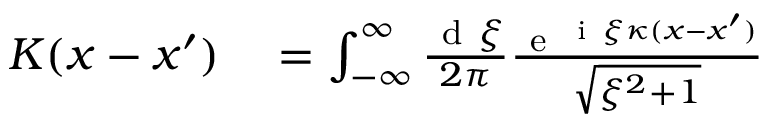<formula> <loc_0><loc_0><loc_500><loc_500>\begin{array} { r l } { K ( x - x ^ { \prime } ) } & = \int _ { - \infty } ^ { \infty } \frac { d \xi } { 2 \pi } \frac { e ^ { i \xi \kappa ( x - x ^ { \prime } ) } } { \sqrt { \xi ^ { 2 } + 1 } } } \end{array}</formula> 